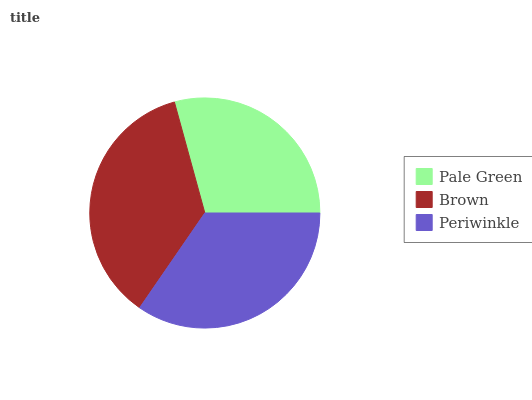Is Pale Green the minimum?
Answer yes or no. Yes. Is Brown the maximum?
Answer yes or no. Yes. Is Periwinkle the minimum?
Answer yes or no. No. Is Periwinkle the maximum?
Answer yes or no. No. Is Brown greater than Periwinkle?
Answer yes or no. Yes. Is Periwinkle less than Brown?
Answer yes or no. Yes. Is Periwinkle greater than Brown?
Answer yes or no. No. Is Brown less than Periwinkle?
Answer yes or no. No. Is Periwinkle the high median?
Answer yes or no. Yes. Is Periwinkle the low median?
Answer yes or no. Yes. Is Brown the high median?
Answer yes or no. No. Is Pale Green the low median?
Answer yes or no. No. 